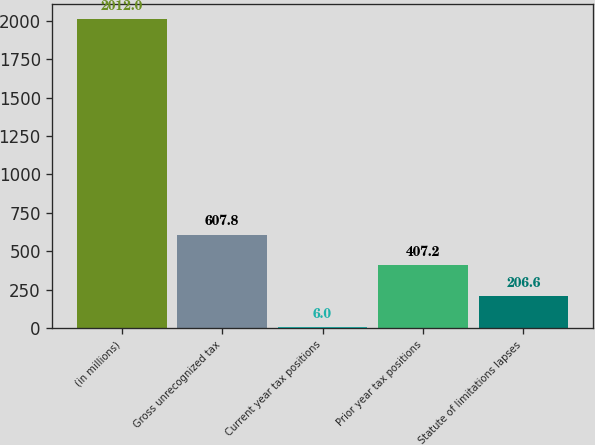Convert chart to OTSL. <chart><loc_0><loc_0><loc_500><loc_500><bar_chart><fcel>(in millions)<fcel>Gross unrecognized tax<fcel>Current year tax positions<fcel>Prior year tax positions<fcel>Statute of limitations lapses<nl><fcel>2012<fcel>607.8<fcel>6<fcel>407.2<fcel>206.6<nl></chart> 